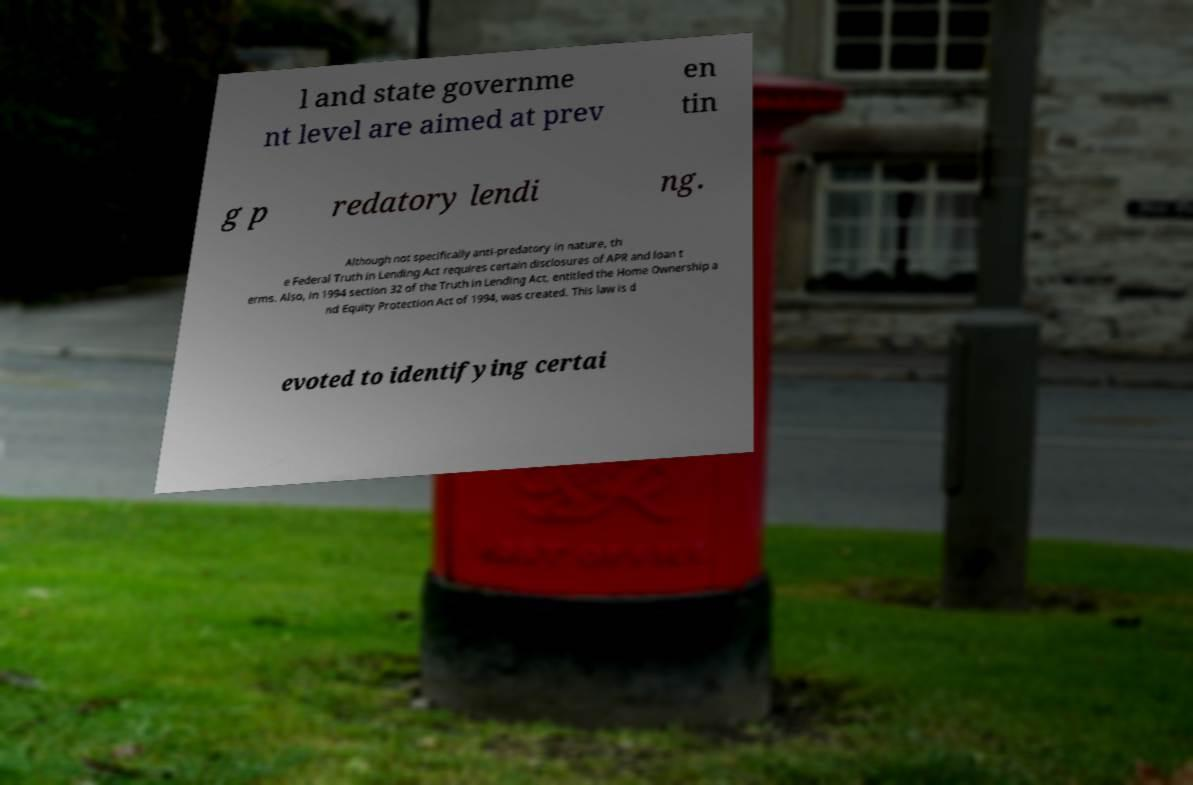Please read and relay the text visible in this image. What does it say? l and state governme nt level are aimed at prev en tin g p redatory lendi ng. Although not specifically anti-predatory in nature, th e Federal Truth in Lending Act requires certain disclosures of APR and loan t erms. Also, in 1994 section 32 of the Truth in Lending Act, entitled the Home Ownership a nd Equity Protection Act of 1994, was created. This law is d evoted to identifying certai 